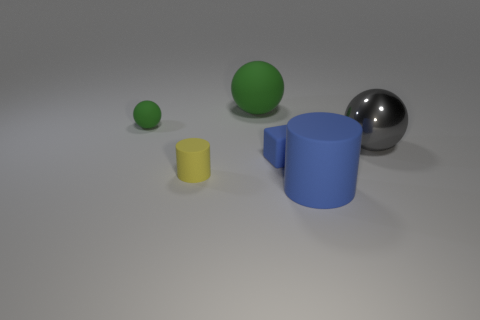What is the shape of the large rubber thing in front of the small green rubber object? cylinder 